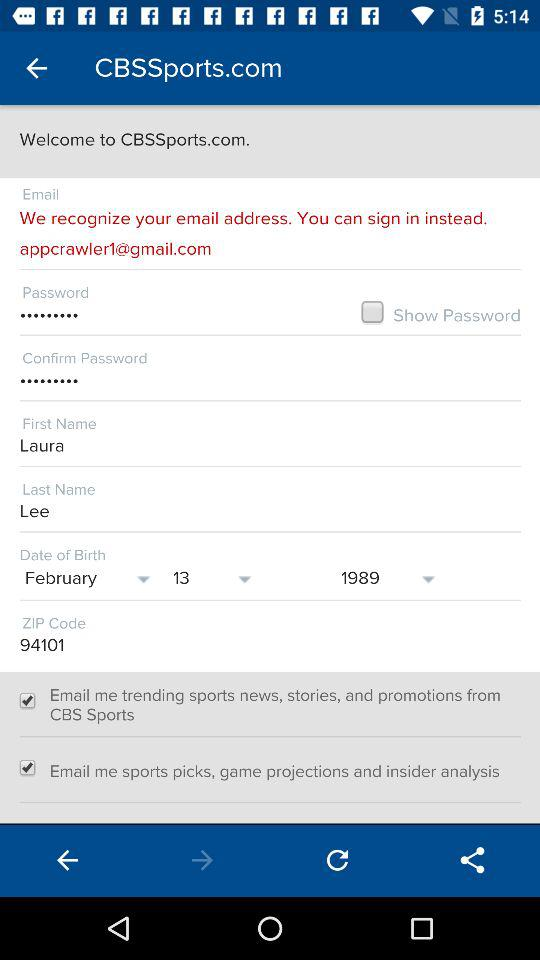What is the name? The name is Laura Lee. 